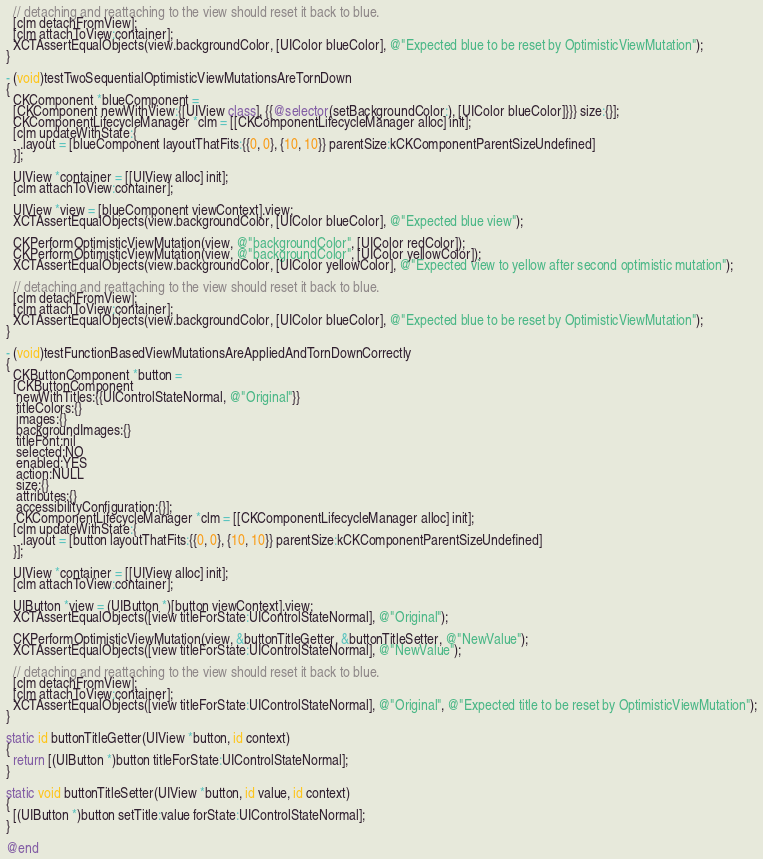Convert code to text. <code><loc_0><loc_0><loc_500><loc_500><_ObjectiveC_>  // detaching and reattaching to the view should reset it back to blue.
  [clm detachFromView];
  [clm attachToView:container];
  XCTAssertEqualObjects(view.backgroundColor, [UIColor blueColor], @"Expected blue to be reset by OptimisticViewMutation");
}

- (void)testTwoSequentialOptimisticViewMutationsAreTornDown
{
  CKComponent *blueComponent =
  [CKComponent newWithView:{[UIView class], {{@selector(setBackgroundColor:), [UIColor blueColor]}}} size:{}];
  CKComponentLifecycleManager *clm = [[CKComponentLifecycleManager alloc] init];
  [clm updateWithState:{
    .layout = [blueComponent layoutThatFits:{{0, 0}, {10, 10}} parentSize:kCKComponentParentSizeUndefined]
  }];

  UIView *container = [[UIView alloc] init];
  [clm attachToView:container];

  UIView *view = [blueComponent viewContext].view;
  XCTAssertEqualObjects(view.backgroundColor, [UIColor blueColor], @"Expected blue view");

  CKPerformOptimisticViewMutation(view, @"backgroundColor", [UIColor redColor]);
  CKPerformOptimisticViewMutation(view, @"backgroundColor", [UIColor yellowColor]);
  XCTAssertEqualObjects(view.backgroundColor, [UIColor yellowColor], @"Expected view to yellow after second optimistic mutation");

  // detaching and reattaching to the view should reset it back to blue.
  [clm detachFromView];
  [clm attachToView:container];
  XCTAssertEqualObjects(view.backgroundColor, [UIColor blueColor], @"Expected blue to be reset by OptimisticViewMutation");
}

- (void)testFunctionBasedViewMutationsAreAppliedAndTornDownCorrectly
{
  CKButtonComponent *button =
  [CKButtonComponent
   newWithTitles:{{UIControlStateNormal, @"Original"}}
   titleColors:{}
   images:{}
   backgroundImages:{}
   titleFont:nil
   selected:NO
   enabled:YES
   action:NULL
   size:{}
   attributes:{}
   accessibilityConfiguration:{}];
   CKComponentLifecycleManager *clm = [[CKComponentLifecycleManager alloc] init];
  [clm updateWithState:{
    .layout = [button layoutThatFits:{{0, 0}, {10, 10}} parentSize:kCKComponentParentSizeUndefined]
  }];

  UIView *container = [[UIView alloc] init];
  [clm attachToView:container];

  UIButton *view = (UIButton *)[button viewContext].view;
  XCTAssertEqualObjects([view titleForState:UIControlStateNormal], @"Original");

  CKPerformOptimisticViewMutation(view, &buttonTitleGetter, &buttonTitleSetter, @"NewValue");
  XCTAssertEqualObjects([view titleForState:UIControlStateNormal], @"NewValue");

  // detaching and reattaching to the view should reset it back to blue.
  [clm detachFromView];
  [clm attachToView:container];
  XCTAssertEqualObjects([view titleForState:UIControlStateNormal], @"Original", @"Expected title to be reset by OptimisticViewMutation");
}

static id buttonTitleGetter(UIView *button, id context)
{
  return [(UIButton *)button titleForState:UIControlStateNormal];
}

static void buttonTitleSetter(UIView *button, id value, id context)
{
  [(UIButton *)button setTitle:value forState:UIControlStateNormal];
}

@end
</code> 